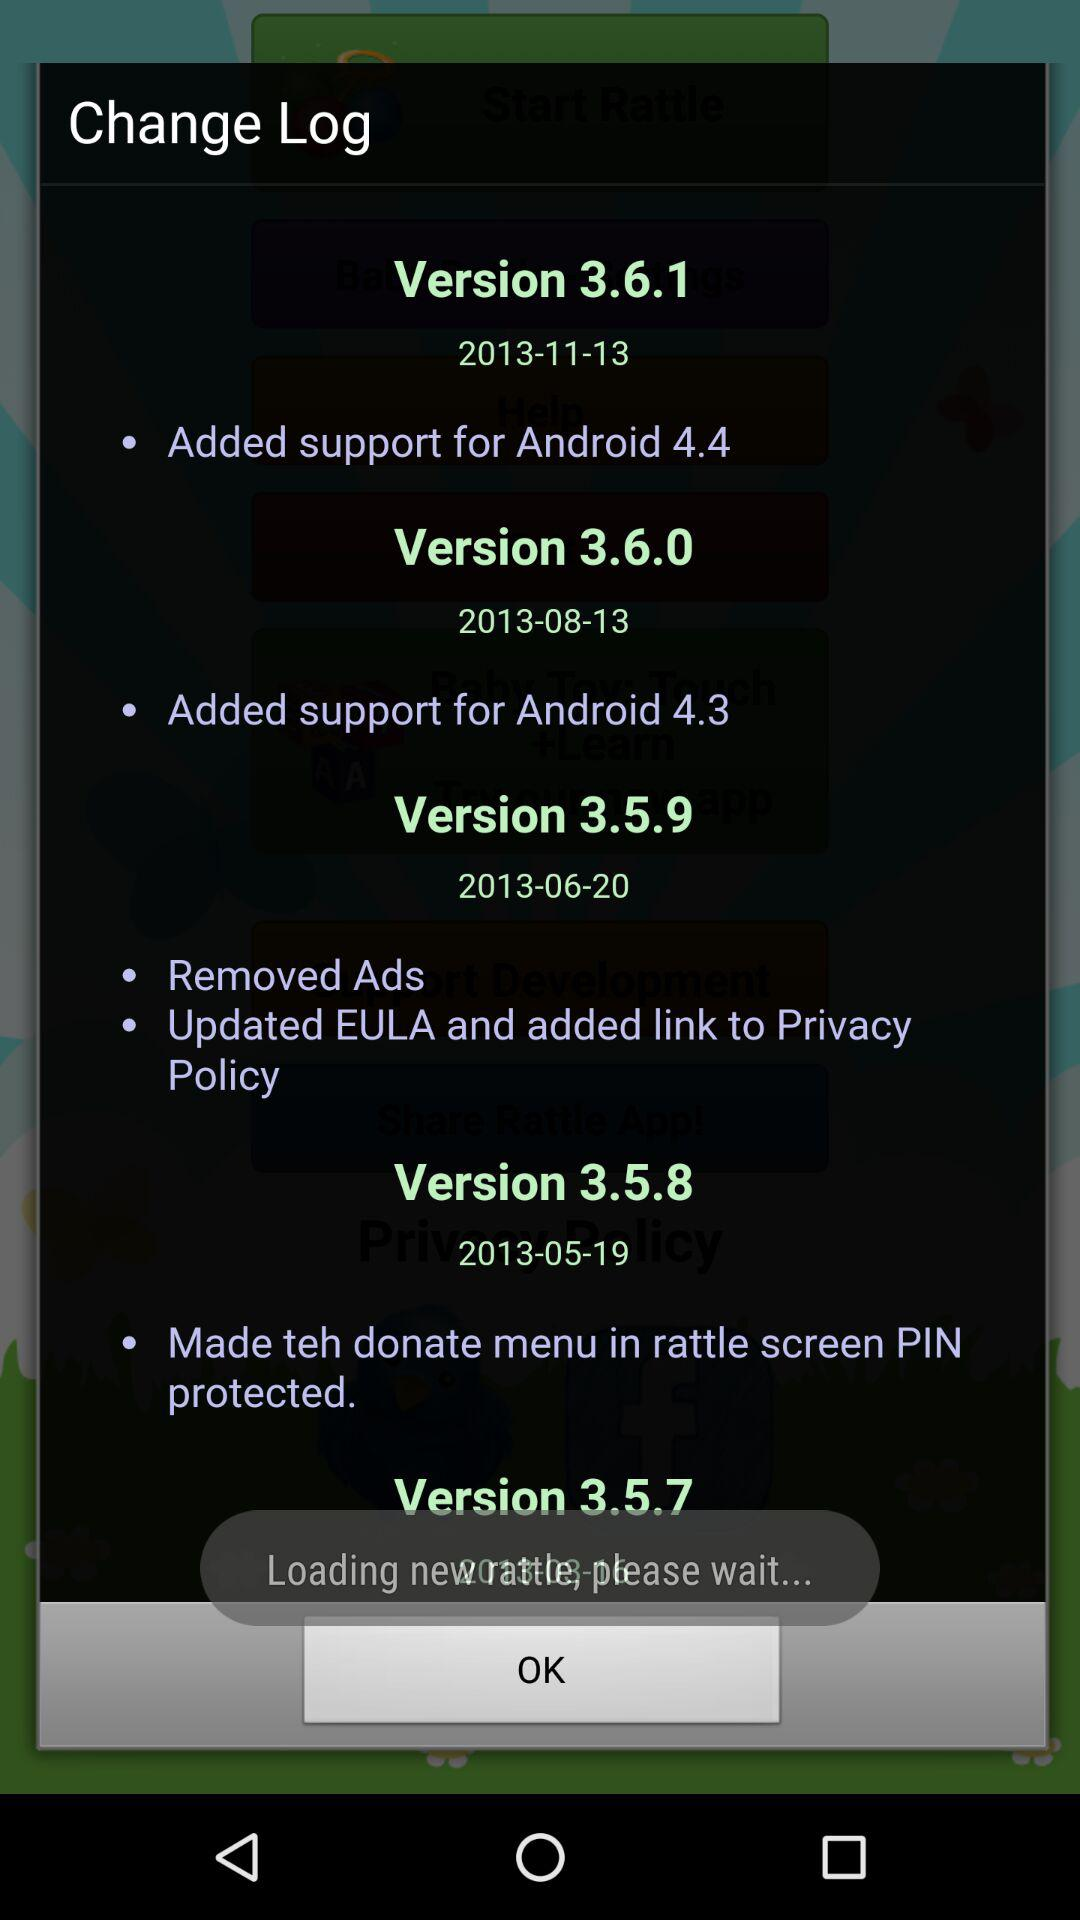What are the new updates in version 3.5.9? The new updates in version 3.5.9 are "Removed Ads" and "Updated EULA and added link to Privacy Policy". 